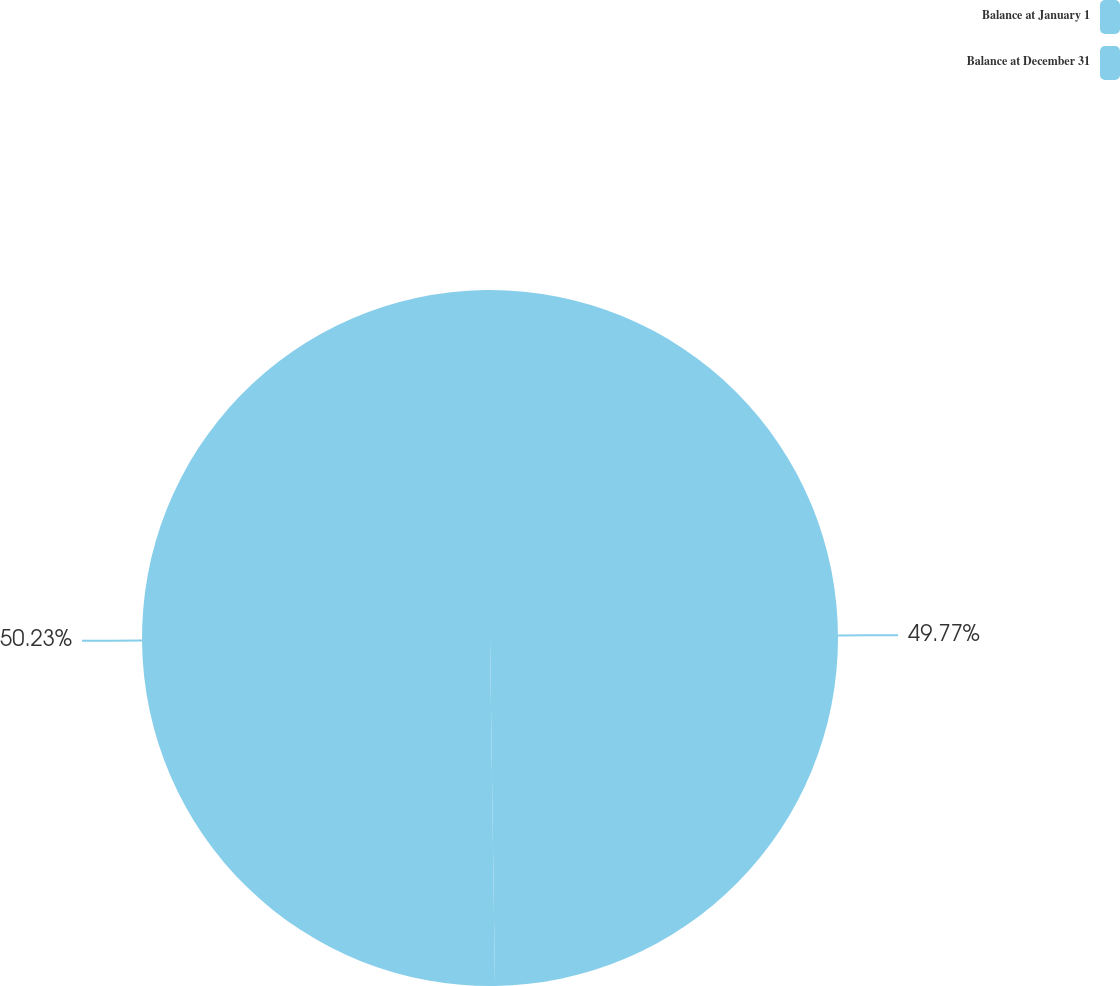<chart> <loc_0><loc_0><loc_500><loc_500><pie_chart><fcel>Balance at January 1<fcel>Balance at December 31<nl><fcel>49.77%<fcel>50.23%<nl></chart> 